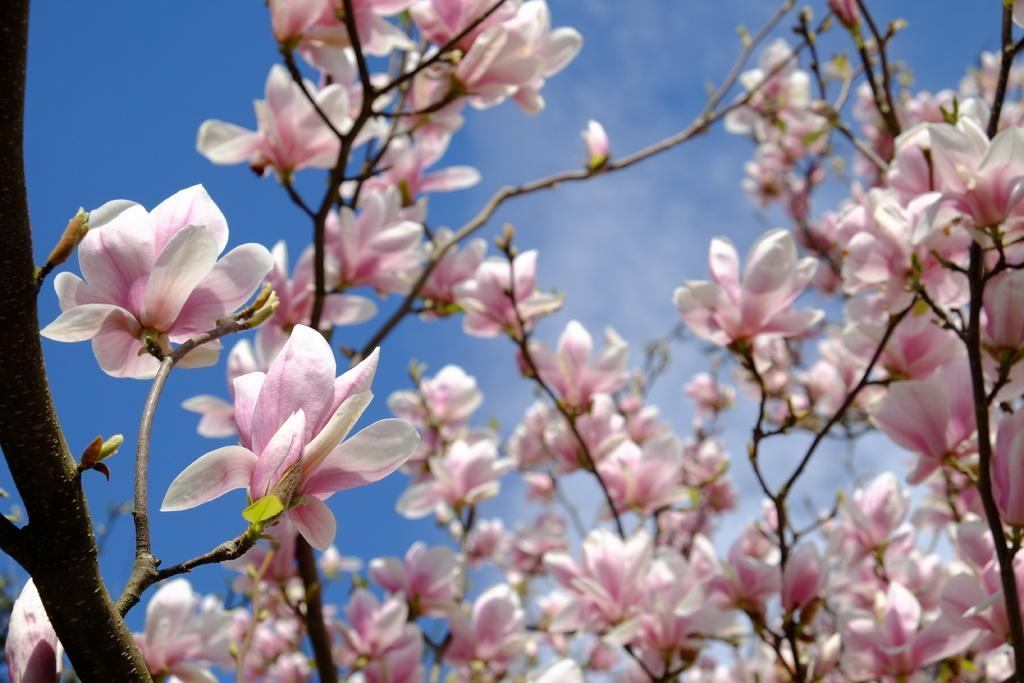Please provide a concise description of this image. In this picture we can see plants with flowers and we can see sky in the background. 